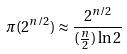Convert formula to latex. <formula><loc_0><loc_0><loc_500><loc_500>\pi ( 2 ^ { n / 2 } ) \approx \frac { 2 ^ { n / 2 } } { ( \frac { n } { 2 } ) \ln 2 }</formula> 